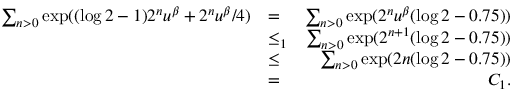<formula> <loc_0><loc_0><loc_500><loc_500>\begin{array} { r l r } { \sum _ { n > 0 } \exp ( ( \log 2 - 1 ) 2 ^ { n } u ^ { \beta } + 2 ^ { n } u ^ { \beta } / 4 ) } & { = } & { \sum _ { n > 0 } \exp ( 2 ^ { n } u ^ { \beta } ( \log 2 - 0 . 7 5 ) ) } \\ & { \leq _ { 1 } } & { \sum _ { n > 0 } \exp ( 2 ^ { n + 1 } ( \log 2 - 0 . 7 5 ) ) } \\ & { \leq } & { \sum _ { n > 0 } \exp ( 2 n ( \log 2 - 0 . 7 5 ) ) } \\ & { = } & { C _ { 1 } . } \end{array}</formula> 